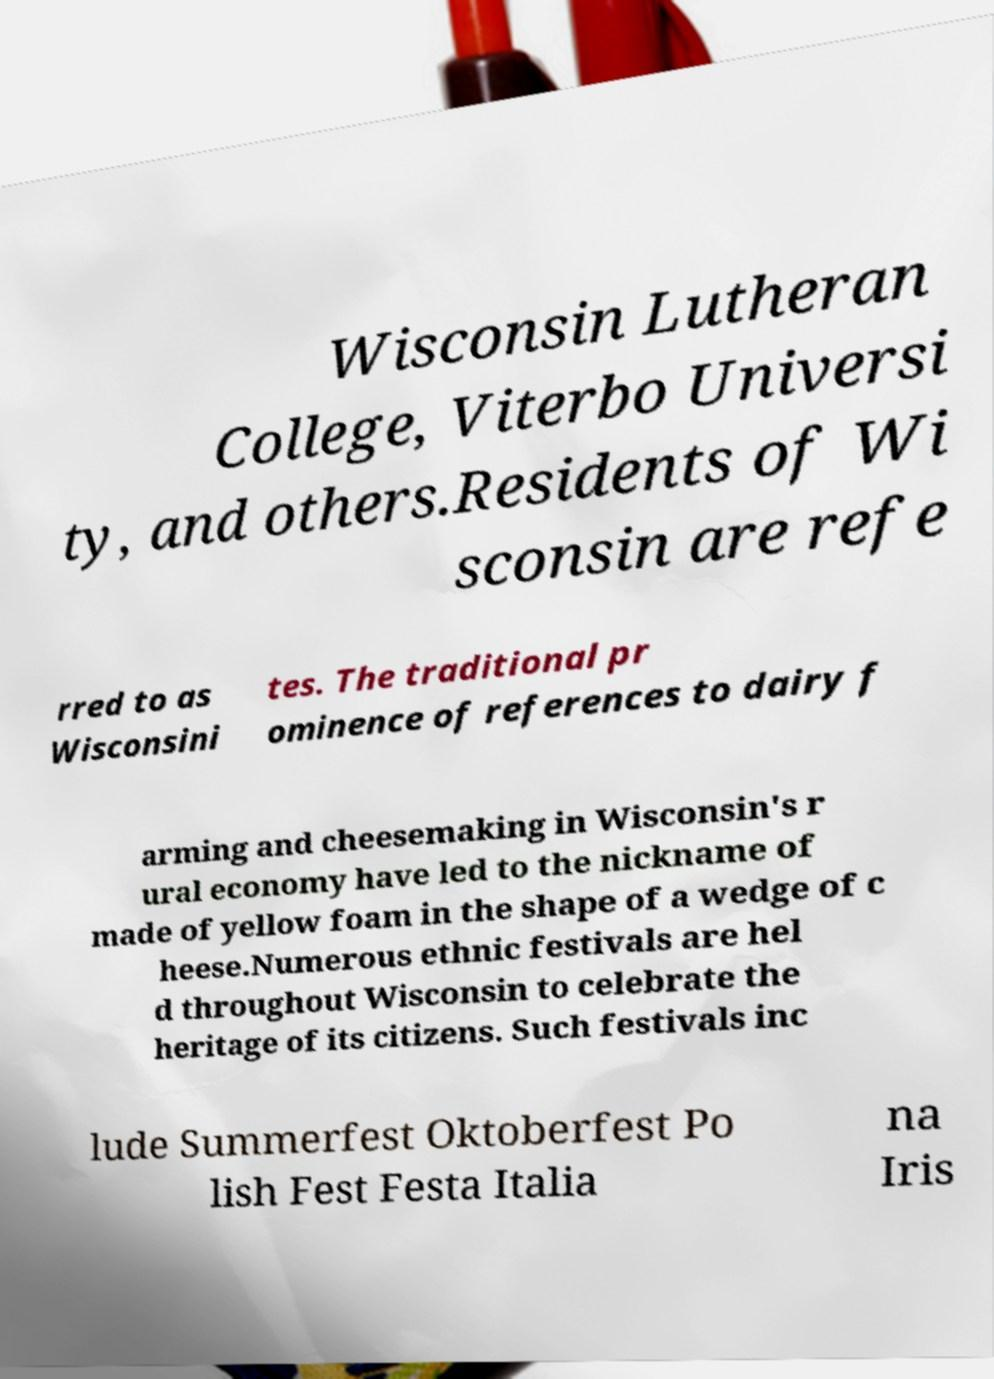There's text embedded in this image that I need extracted. Can you transcribe it verbatim? Wisconsin Lutheran College, Viterbo Universi ty, and others.Residents of Wi sconsin are refe rred to as Wisconsini tes. The traditional pr ominence of references to dairy f arming and cheesemaking in Wisconsin's r ural economy have led to the nickname of made of yellow foam in the shape of a wedge of c heese.Numerous ethnic festivals are hel d throughout Wisconsin to celebrate the heritage of its citizens. Such festivals inc lude Summerfest Oktoberfest Po lish Fest Festa Italia na Iris 